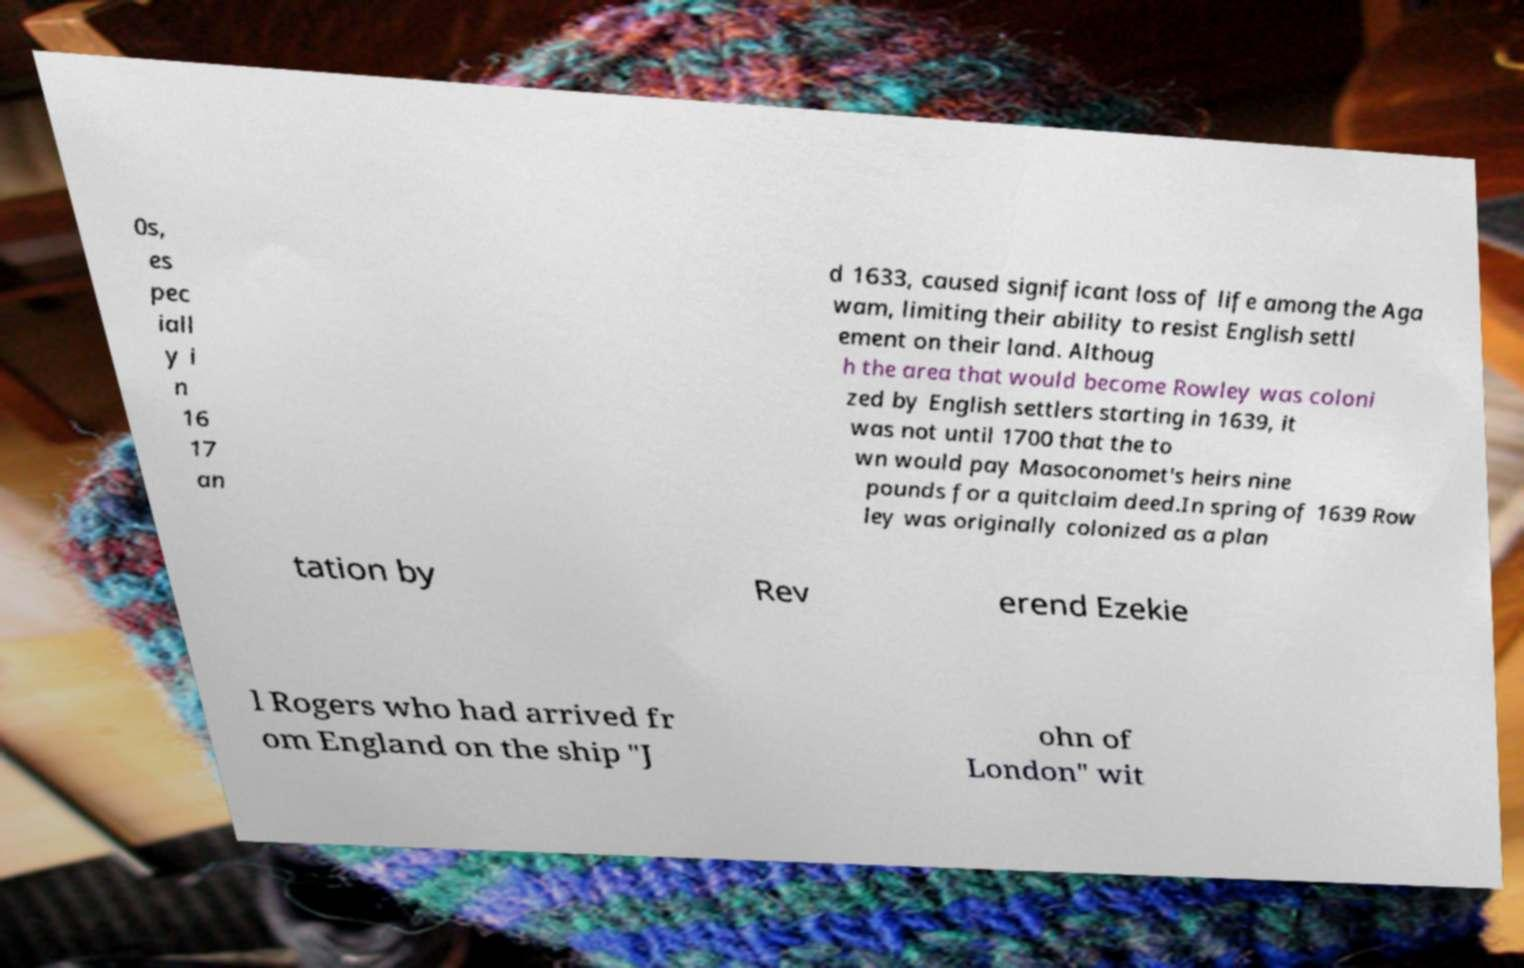Could you extract and type out the text from this image? 0s, es pec iall y i n 16 17 an d 1633, caused significant loss of life among the Aga wam, limiting their ability to resist English settl ement on their land. Althoug h the area that would become Rowley was coloni zed by English settlers starting in 1639, it was not until 1700 that the to wn would pay Masoconomet's heirs nine pounds for a quitclaim deed.In spring of 1639 Row ley was originally colonized as a plan tation by Rev erend Ezekie l Rogers who had arrived fr om England on the ship "J ohn of London" wit 